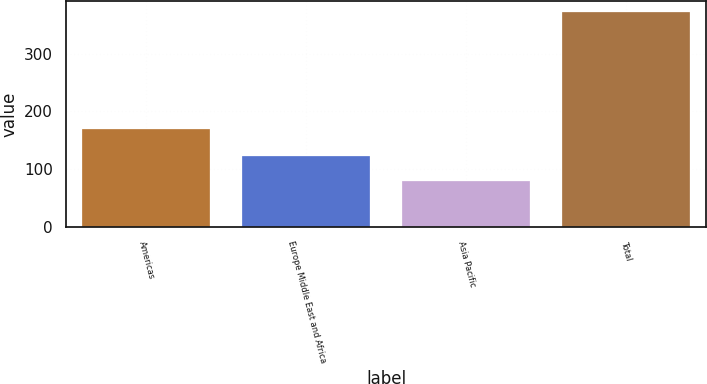Convert chart to OTSL. <chart><loc_0><loc_0><loc_500><loc_500><bar_chart><fcel>Americas<fcel>Europe Middle East and Africa<fcel>Asia Pacific<fcel>Total<nl><fcel>169<fcel>123<fcel>80<fcel>372<nl></chart> 